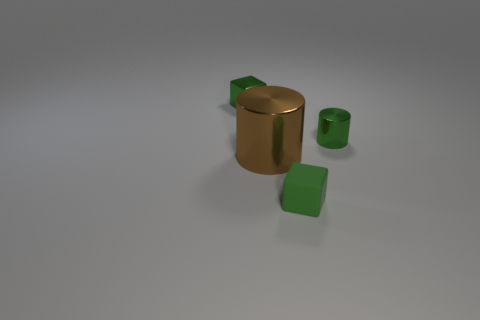Add 2 small metal objects. How many objects exist? 6 Add 1 large brown objects. How many large brown objects are left? 2 Add 2 yellow shiny blocks. How many yellow shiny blocks exist? 2 Subtract 1 green cubes. How many objects are left? 3 Subtract all large blue cylinders. Subtract all tiny green rubber blocks. How many objects are left? 3 